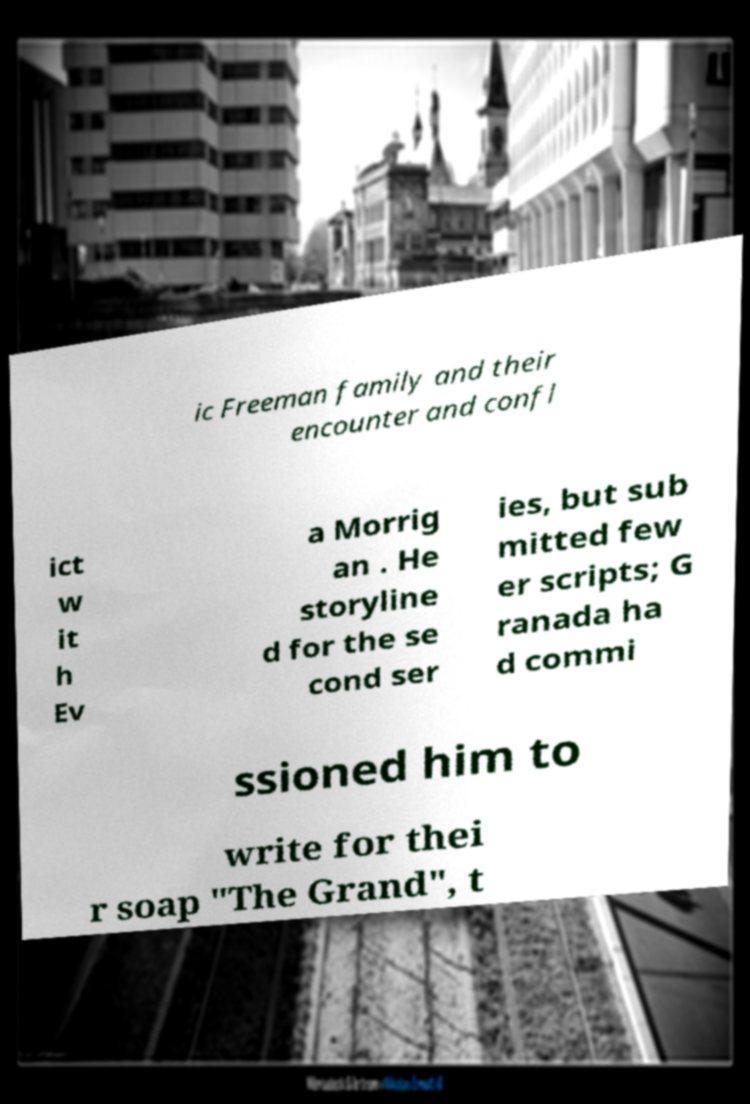What messages or text are displayed in this image? I need them in a readable, typed format. ic Freeman family and their encounter and confl ict w it h Ev a Morrig an . He storyline d for the se cond ser ies, but sub mitted few er scripts; G ranada ha d commi ssioned him to write for thei r soap "The Grand", t 